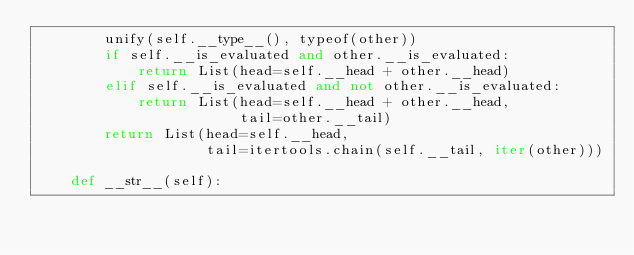Convert code to text. <code><loc_0><loc_0><loc_500><loc_500><_Python_>        unify(self.__type__(), typeof(other))
        if self.__is_evaluated and other.__is_evaluated:
            return List(head=self.__head + other.__head)
        elif self.__is_evaluated and not other.__is_evaluated:
            return List(head=self.__head + other.__head,
                        tail=other.__tail)
        return List(head=self.__head,
                    tail=itertools.chain(self.__tail, iter(other)))

    def __str__(self):</code> 